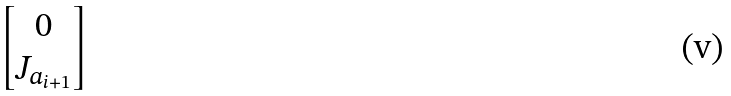<formula> <loc_0><loc_0><loc_500><loc_500>\begin{bmatrix} 0 \\ J _ { a _ { i + 1 } } \end{bmatrix}</formula> 